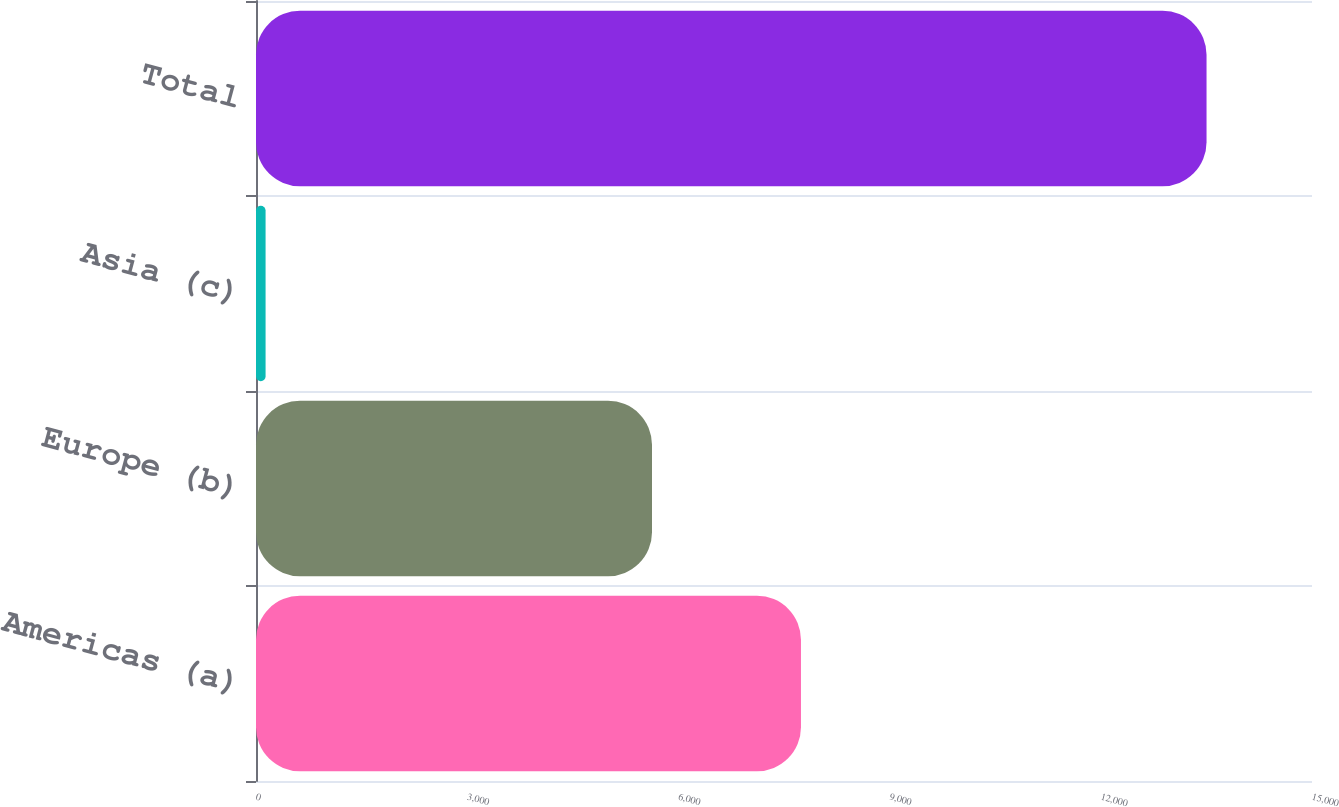Convert chart to OTSL. <chart><loc_0><loc_0><loc_500><loc_500><bar_chart><fcel>The Americas (a)<fcel>Europe (b)<fcel>Asia (c)<fcel>Total<nl><fcel>7741<fcel>5625<fcel>136<fcel>13502<nl></chart> 